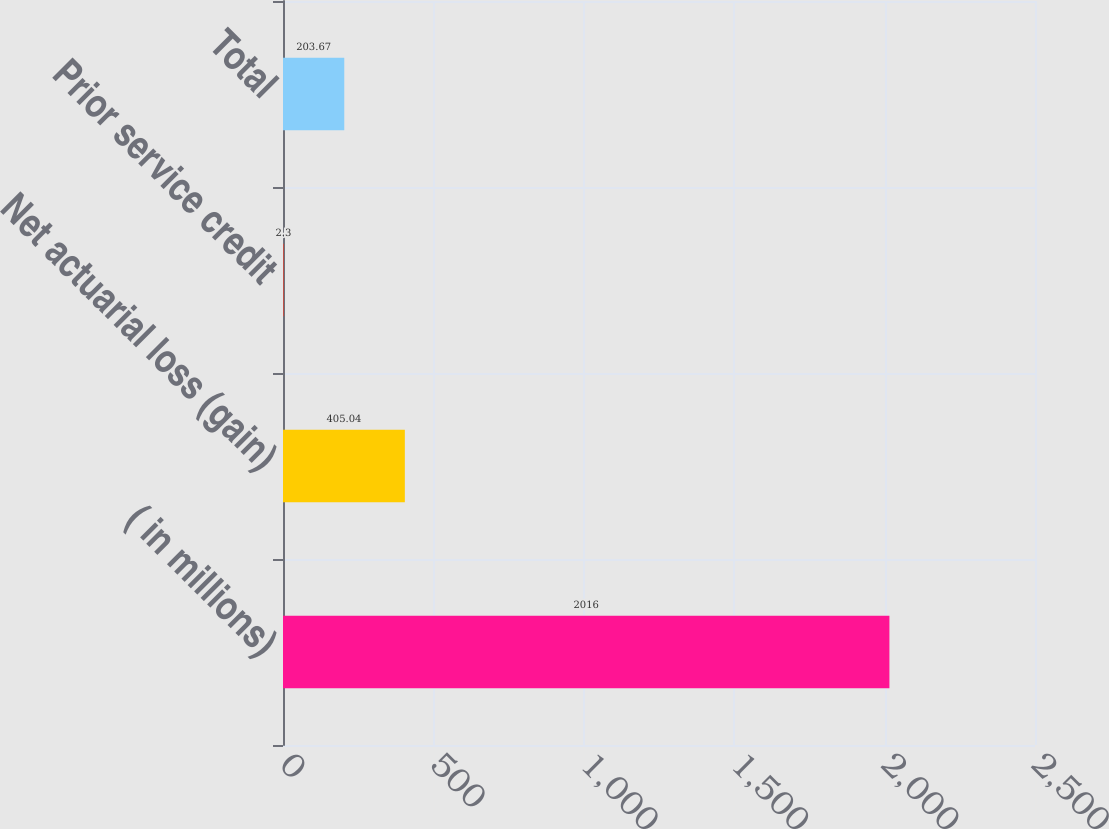Convert chart to OTSL. <chart><loc_0><loc_0><loc_500><loc_500><bar_chart><fcel>( in millions)<fcel>Net actuarial loss (gain)<fcel>Prior service credit<fcel>Total<nl><fcel>2016<fcel>405.04<fcel>2.3<fcel>203.67<nl></chart> 